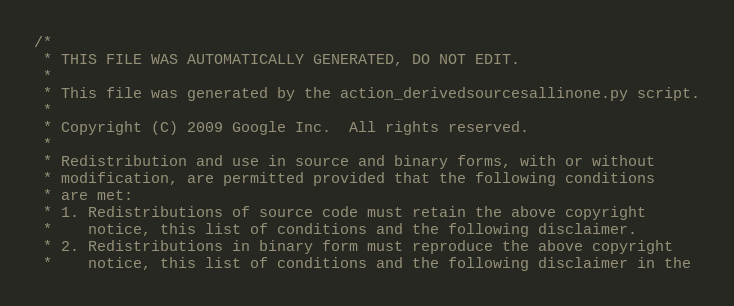Convert code to text. <code><loc_0><loc_0><loc_500><loc_500><_C++_>/*
 * THIS FILE WAS AUTOMATICALLY GENERATED, DO NOT EDIT.
 *
 * This file was generated by the action_derivedsourcesallinone.py script.
 *
 * Copyright (C) 2009 Google Inc.  All rights reserved.
 *
 * Redistribution and use in source and binary forms, with or without
 * modification, are permitted provided that the following conditions
 * are met:
 * 1. Redistributions of source code must retain the above copyright
 *    notice, this list of conditions and the following disclaimer.
 * 2. Redistributions in binary form must reproduce the above copyright
 *    notice, this list of conditions and the following disclaimer in the</code> 